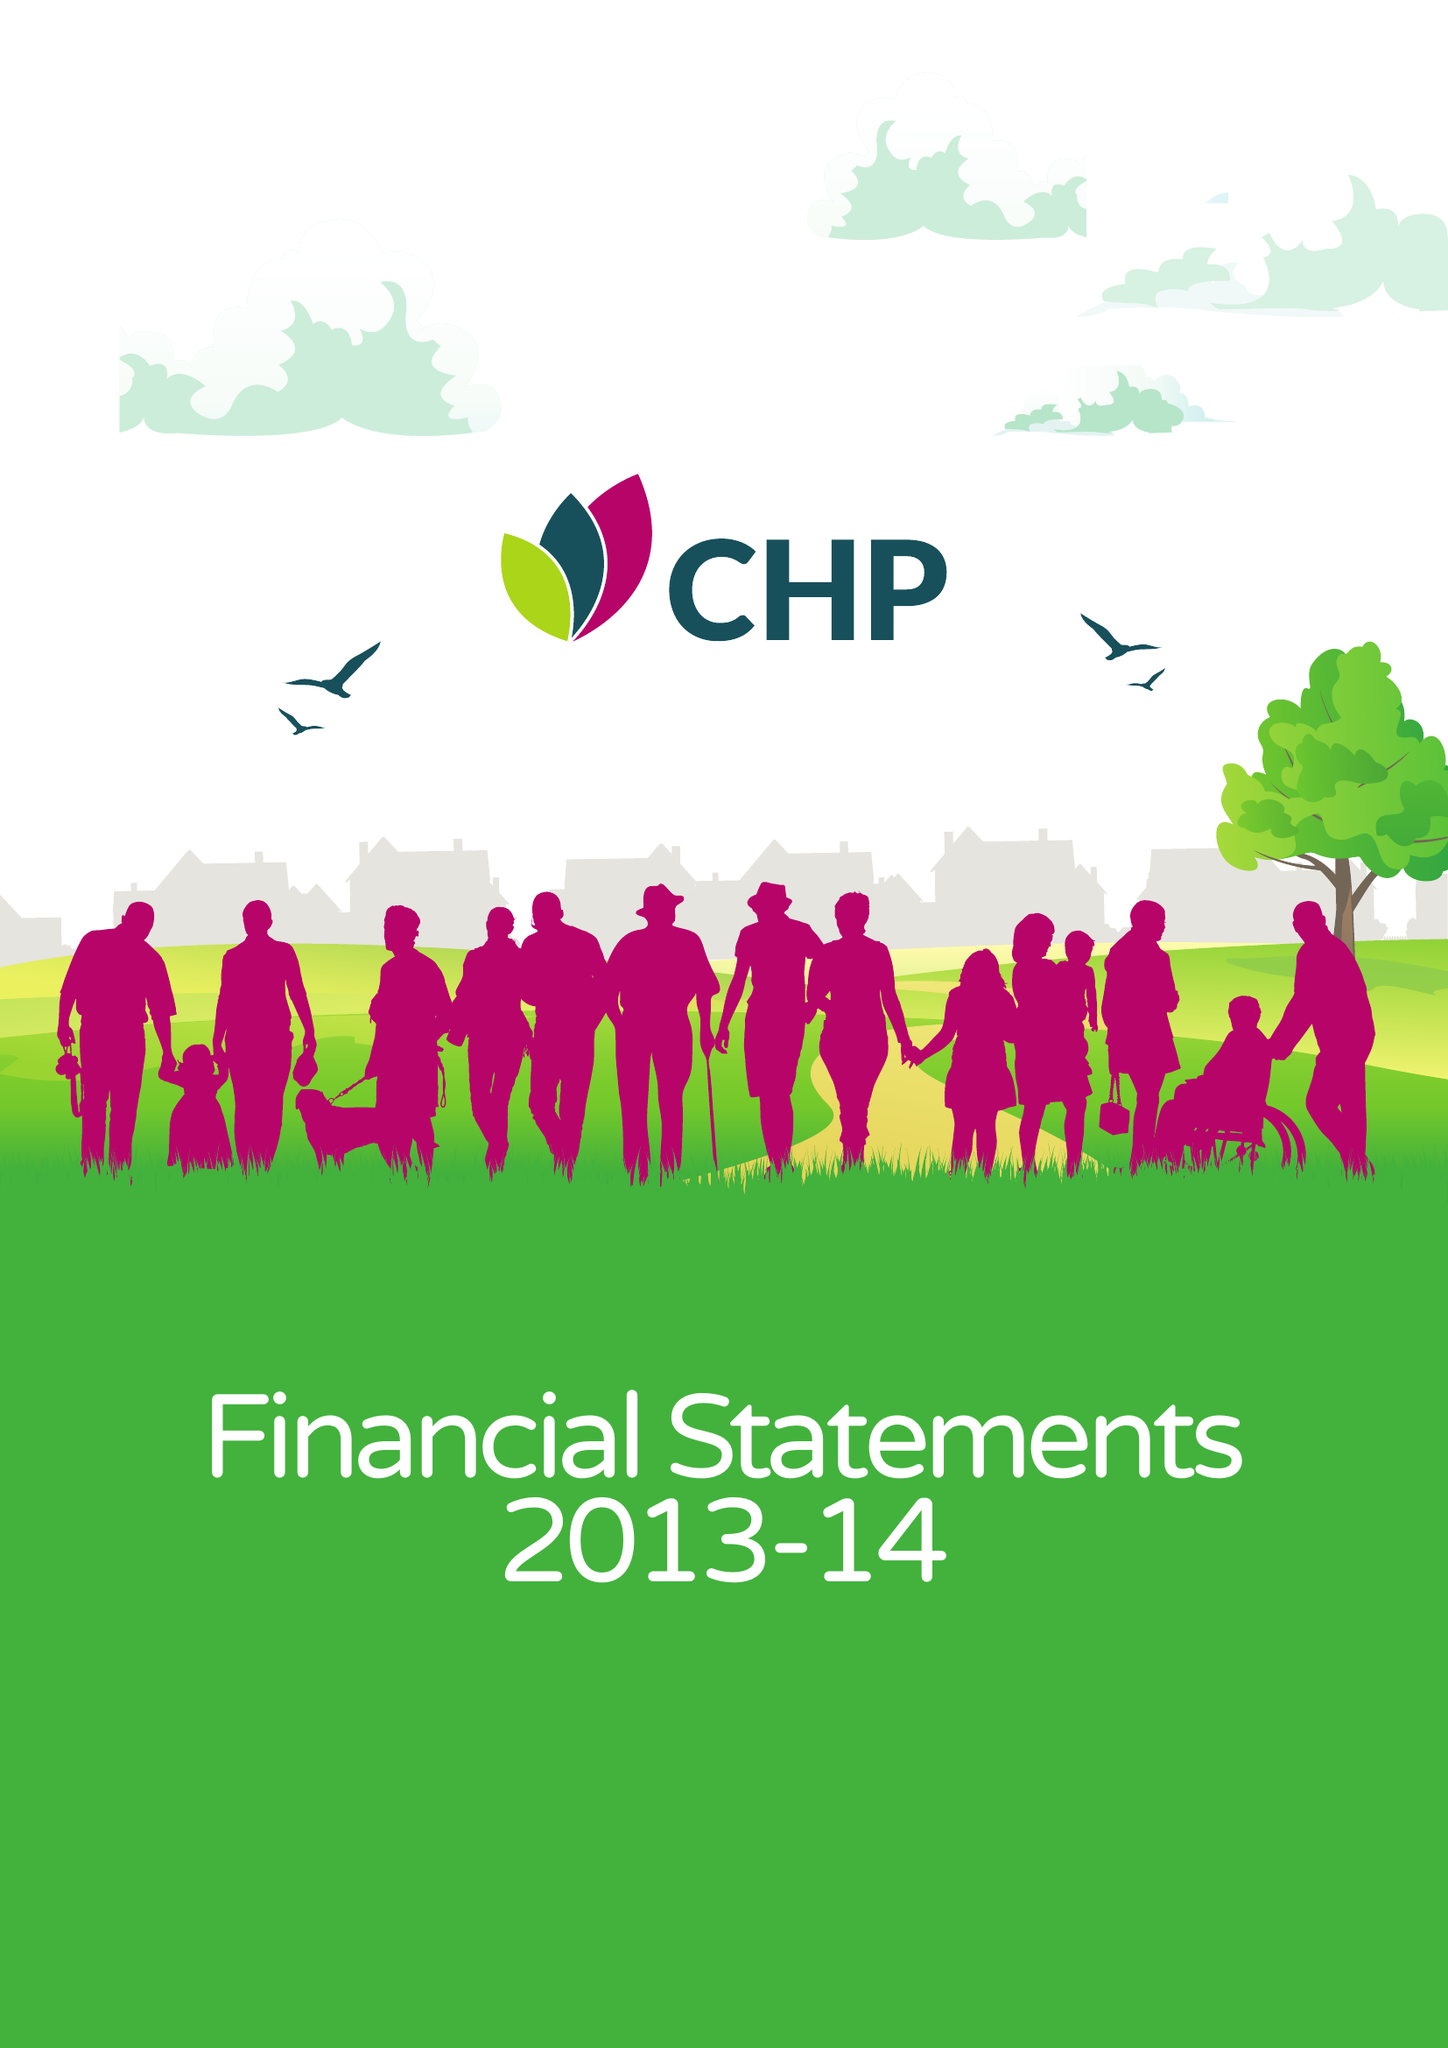What is the value for the address__postcode?
Answer the question using a single word or phrase. CM2 5LB 